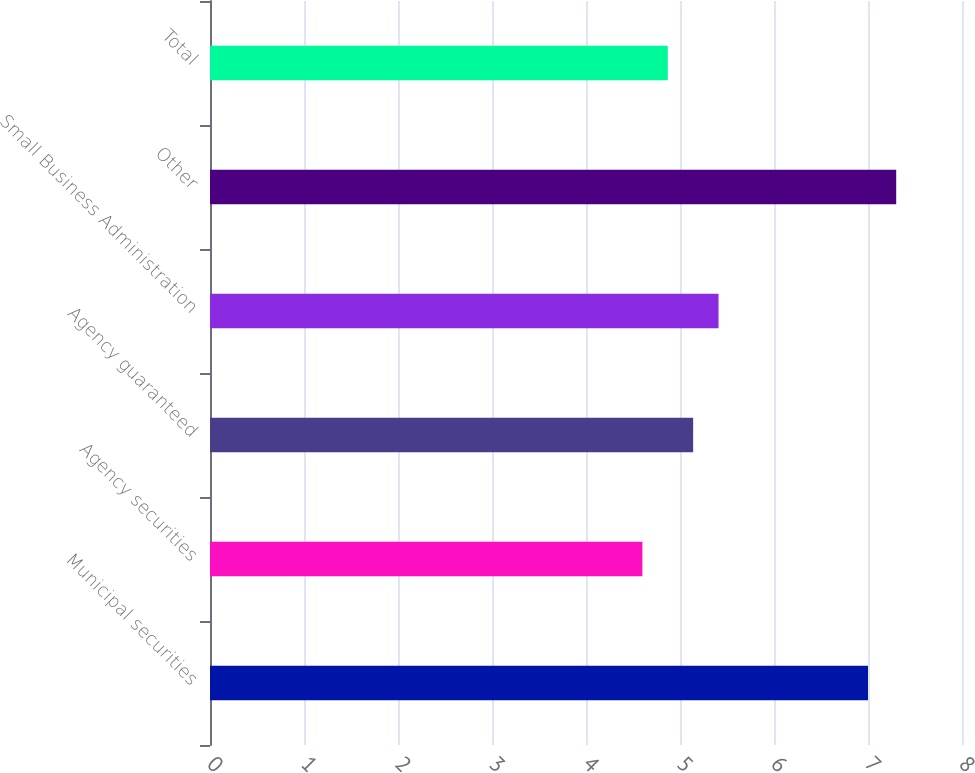Convert chart. <chart><loc_0><loc_0><loc_500><loc_500><bar_chart><fcel>Municipal securities<fcel>Agency securities<fcel>Agency guaranteed<fcel>Small Business Administration<fcel>Other<fcel>Total<nl><fcel>7<fcel>4.6<fcel>5.14<fcel>5.41<fcel>7.3<fcel>4.87<nl></chart> 